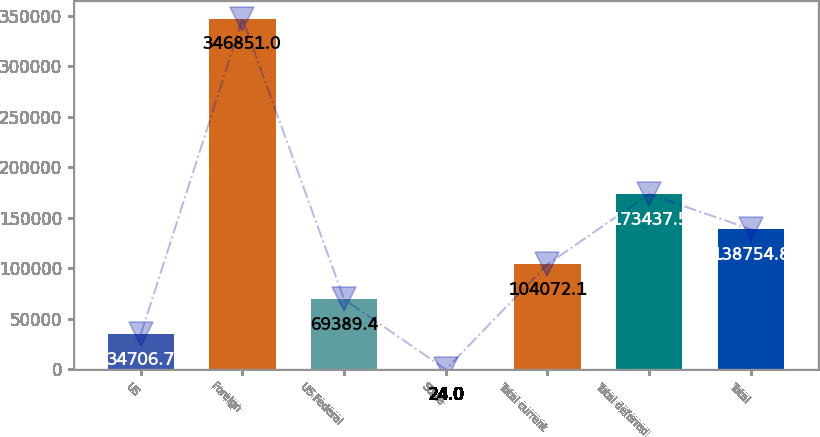Convert chart. <chart><loc_0><loc_0><loc_500><loc_500><bar_chart><fcel>US<fcel>Foreign<fcel>US Federal<fcel>State<fcel>Total current<fcel>Total deferred<fcel>Total<nl><fcel>34706.7<fcel>346851<fcel>69389.4<fcel>24<fcel>104072<fcel>173438<fcel>138755<nl></chart> 